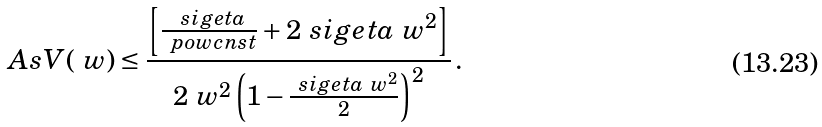Convert formula to latex. <formula><loc_0><loc_0><loc_500><loc_500>A s V ( \ w ) \leq \frac { \left [ \frac { \ s i g e t a } { \ p o w c n s t } + 2 \ s i g e t a \ w ^ { 2 } \right ] } { 2 \ w ^ { 2 } \left ( 1 - \frac { \ s i g e t a \ w ^ { 2 } } { 2 } \right ) ^ { 2 } } \, .</formula> 